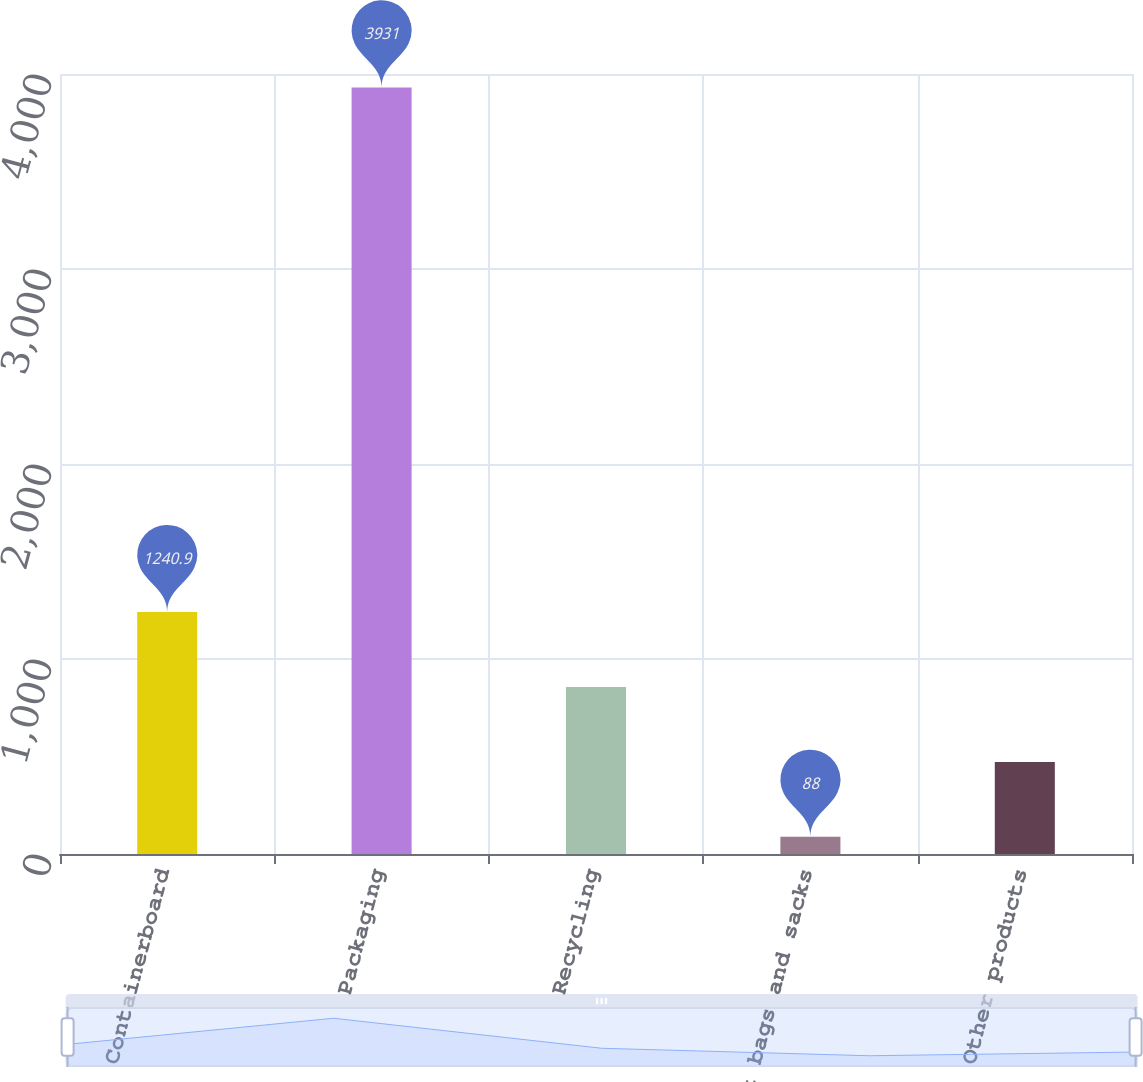Convert chart to OTSL. <chart><loc_0><loc_0><loc_500><loc_500><bar_chart><fcel>Containerboard<fcel>Packaging<fcel>Recycling<fcel>Kraft bags and sacks<fcel>Other products<nl><fcel>1240.9<fcel>3931<fcel>856.6<fcel>88<fcel>472.3<nl></chart> 